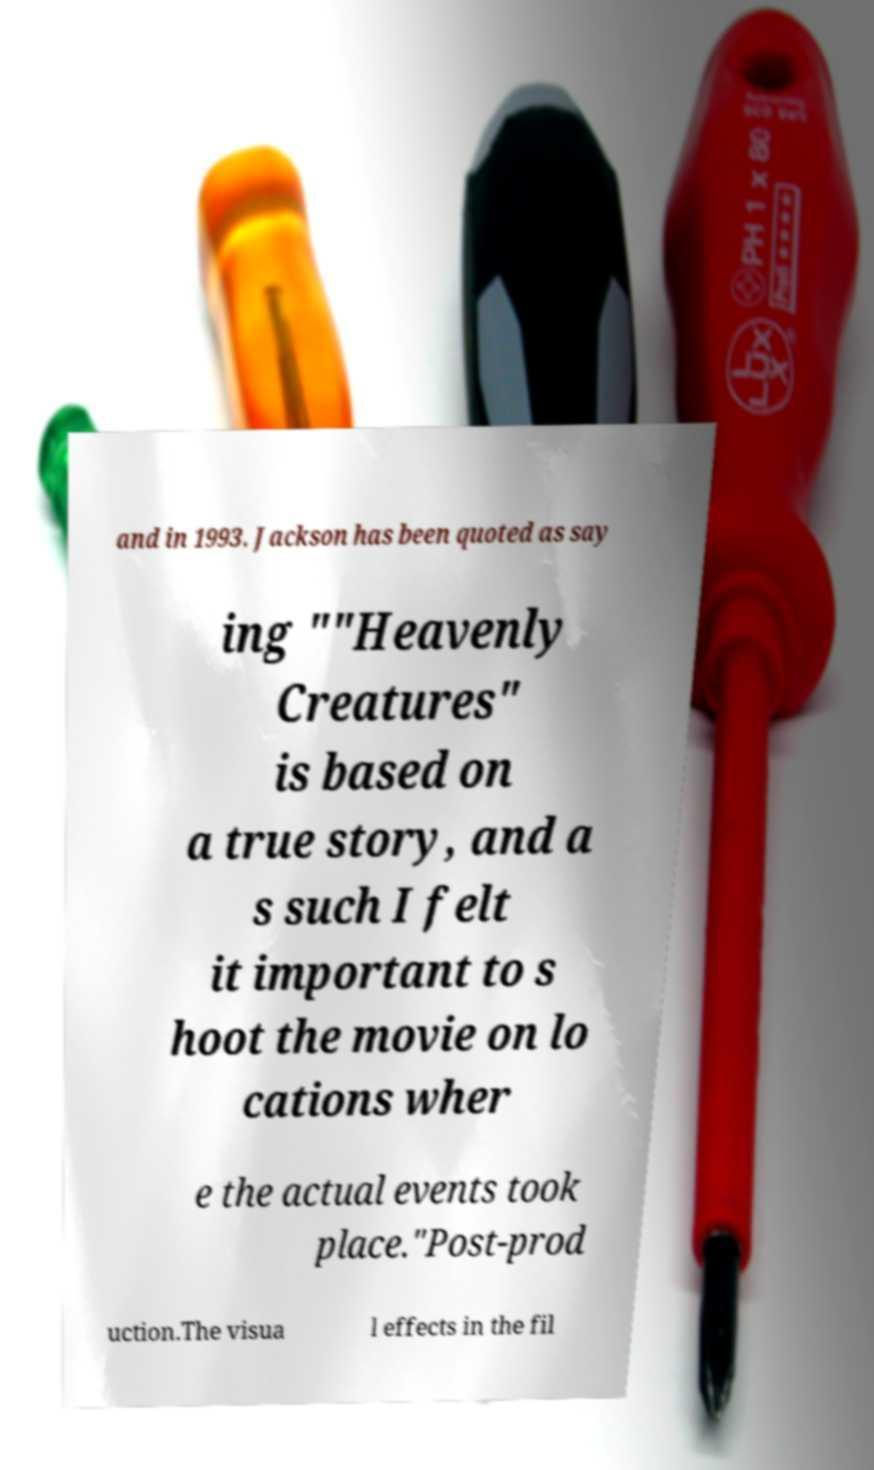Please identify and transcribe the text found in this image. and in 1993. Jackson has been quoted as say ing ""Heavenly Creatures" is based on a true story, and a s such I felt it important to s hoot the movie on lo cations wher e the actual events took place."Post-prod uction.The visua l effects in the fil 